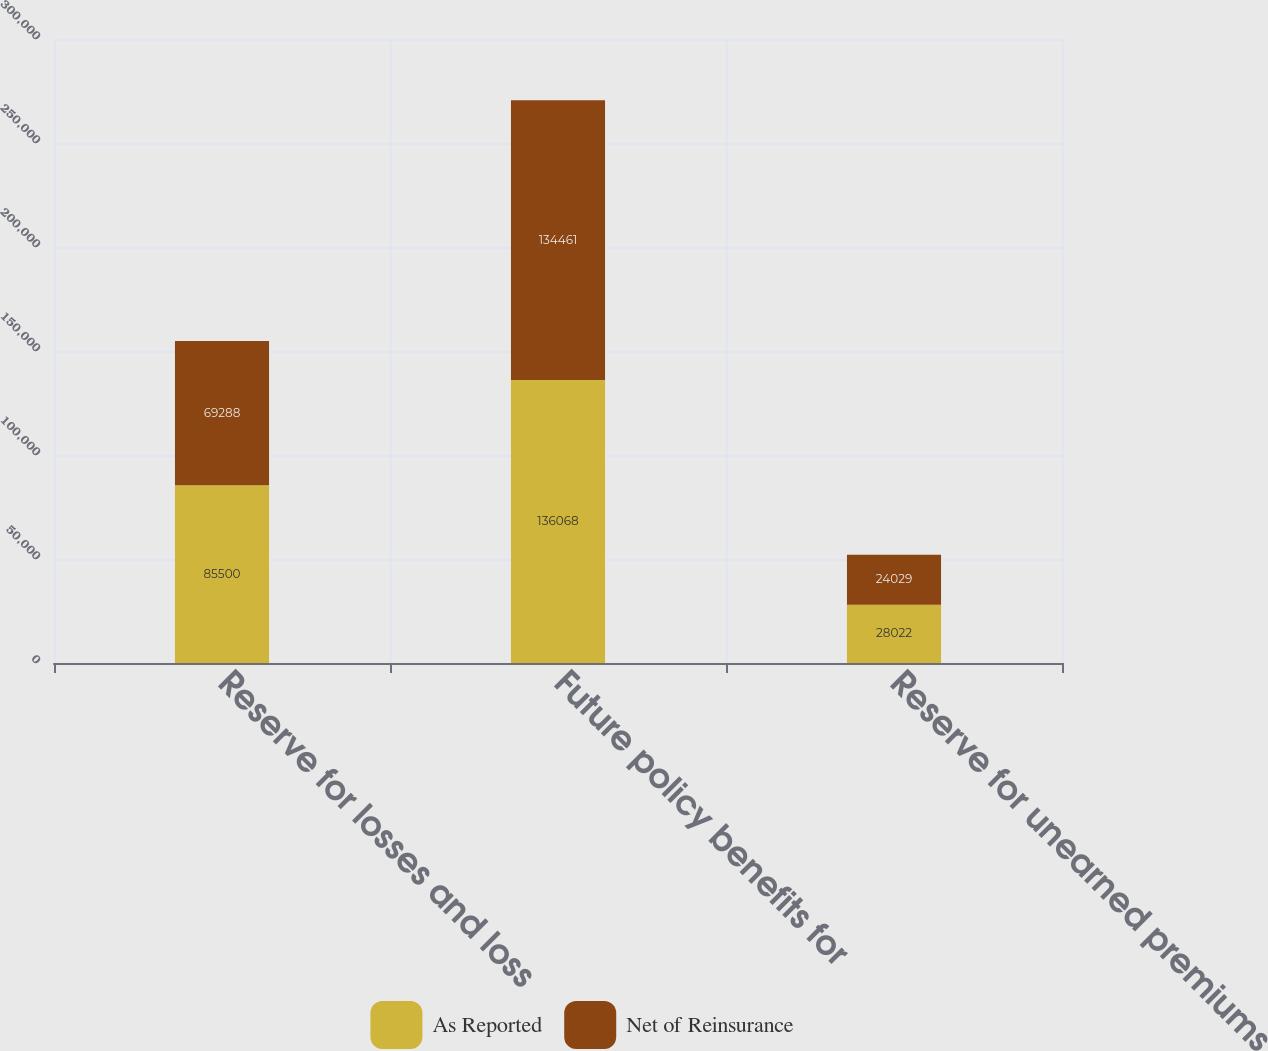<chart> <loc_0><loc_0><loc_500><loc_500><stacked_bar_chart><ecel><fcel>Reserve for losses and loss<fcel>Future policy benefits for<fcel>Reserve for unearned premiums<nl><fcel>As Reported<fcel>85500<fcel>136068<fcel>28022<nl><fcel>Net of Reinsurance<fcel>69288<fcel>134461<fcel>24029<nl></chart> 